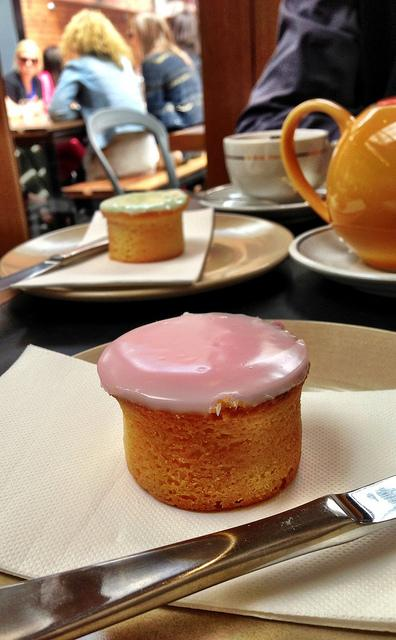What kitchen cooker is necessary for this treat's preparation? Please explain your reasoning. oven. Ovens are needed to bake cakes. 